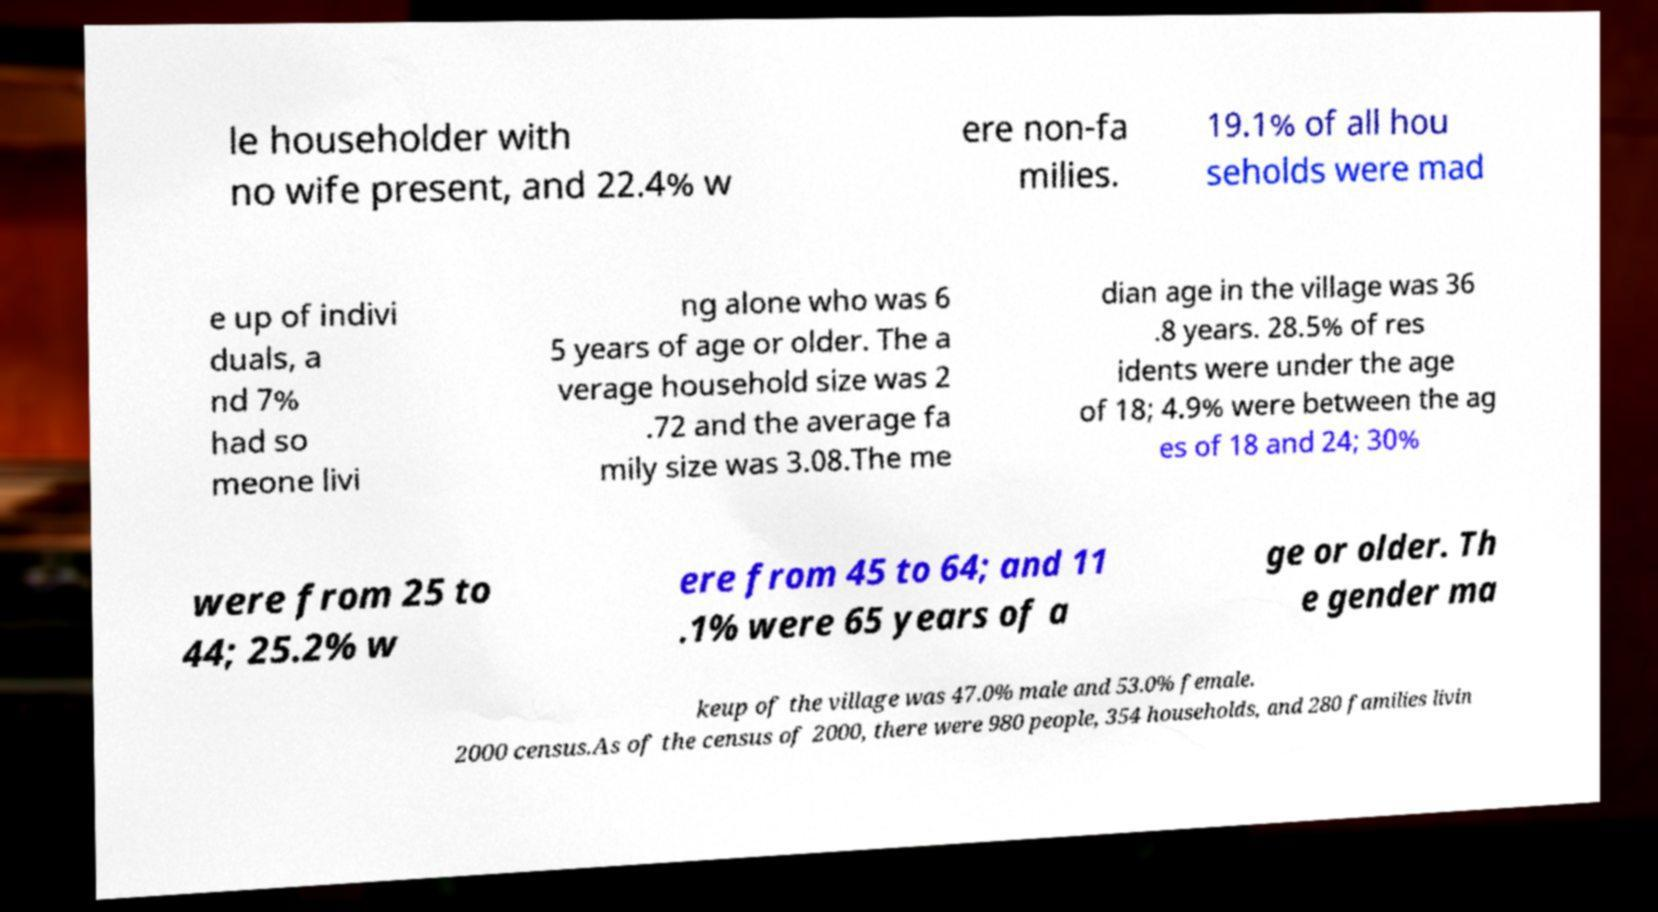Can you accurately transcribe the text from the provided image for me? le householder with no wife present, and 22.4% w ere non-fa milies. 19.1% of all hou seholds were mad e up of indivi duals, a nd 7% had so meone livi ng alone who was 6 5 years of age or older. The a verage household size was 2 .72 and the average fa mily size was 3.08.The me dian age in the village was 36 .8 years. 28.5% of res idents were under the age of 18; 4.9% were between the ag es of 18 and 24; 30% were from 25 to 44; 25.2% w ere from 45 to 64; and 11 .1% were 65 years of a ge or older. Th e gender ma keup of the village was 47.0% male and 53.0% female. 2000 census.As of the census of 2000, there were 980 people, 354 households, and 280 families livin 